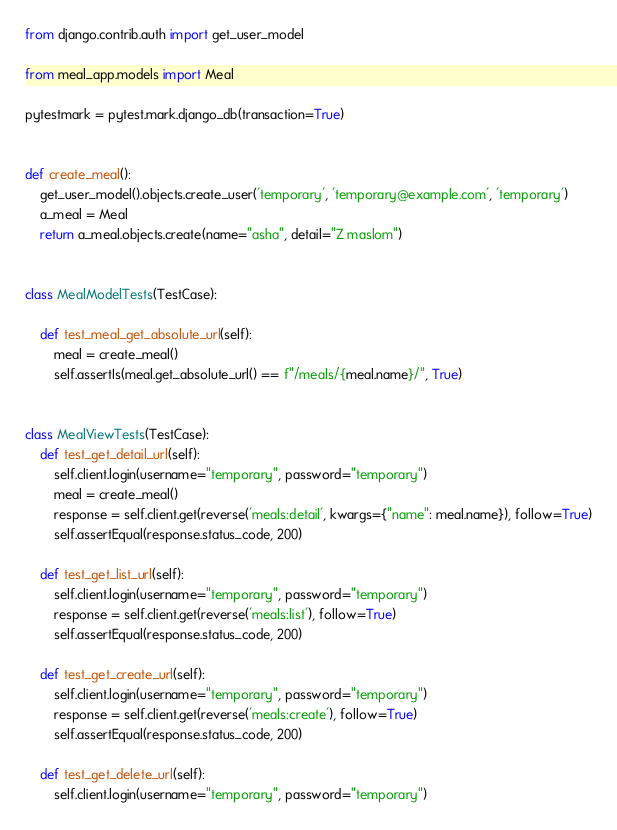<code> <loc_0><loc_0><loc_500><loc_500><_Python_>from django.contrib.auth import get_user_model

from meal_app.models import Meal

pytestmark = pytest.mark.django_db(transaction=True)


def create_meal():
    get_user_model().objects.create_user('temporary', 'temporary@example.com', 'temporary')
    a_meal = Meal
    return a_meal.objects.create(name="asha", detail="Z maslom")


class MealModelTests(TestCase):

    def test_meal_get_absolute_url(self):
        meal = create_meal()
        self.assertIs(meal.get_absolute_url() == f"/meals/{meal.name}/", True)


class MealViewTests(TestCase):
    def test_get_detail_url(self):
        self.client.login(username="temporary", password="temporary")
        meal = create_meal()
        response = self.client.get(reverse('meals:detail', kwargs={"name": meal.name}), follow=True)
        self.assertEqual(response.status_code, 200)

    def test_get_list_url(self):
        self.client.login(username="temporary", password="temporary")
        response = self.client.get(reverse('meals:list'), follow=True)
        self.assertEqual(response.status_code, 200)

    def test_get_create_url(self):
        self.client.login(username="temporary", password="temporary")
        response = self.client.get(reverse('meals:create'), follow=True)
        self.assertEqual(response.status_code, 200)

    def test_get_delete_url(self):
        self.client.login(username="temporary", password="temporary")</code> 